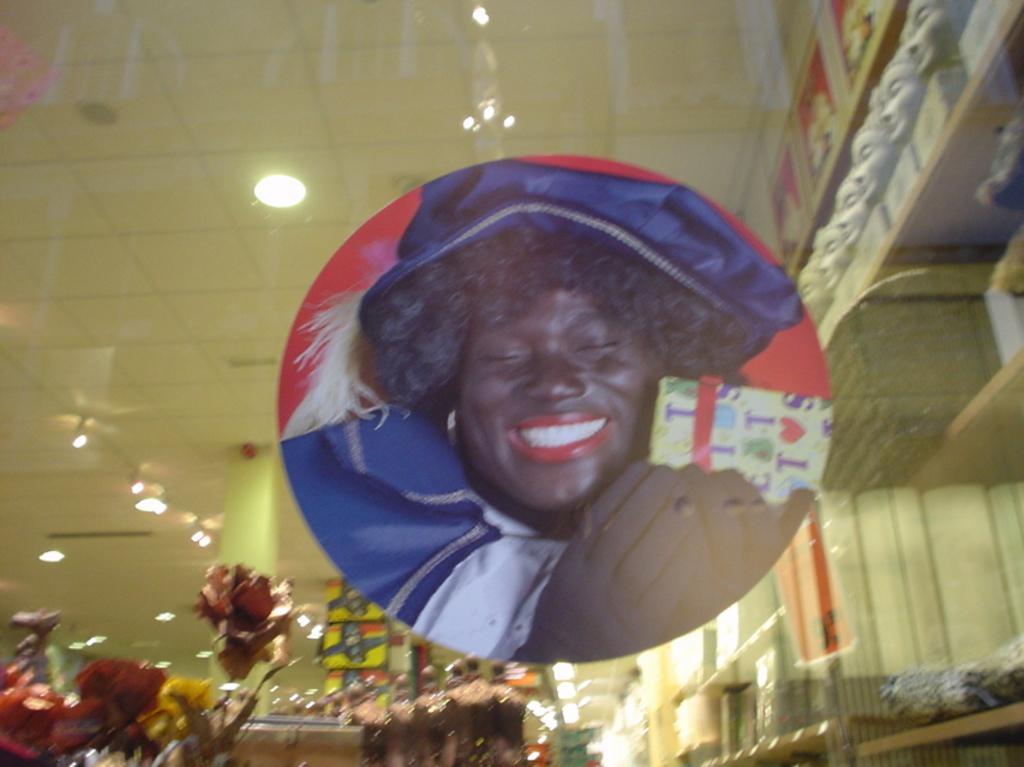How would you summarize this image in a sentence or two? In the center of the image, we can see a picture of a person smiling and in the background, there are flower pots, shelves and we can see some structures. At the top, there is roof and we can see lights. 